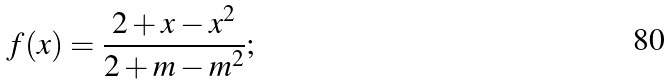<formula> <loc_0><loc_0><loc_500><loc_500>f ( x ) = \frac { 2 + x - x ^ { 2 } } { 2 + m - m ^ { 2 } } ;</formula> 